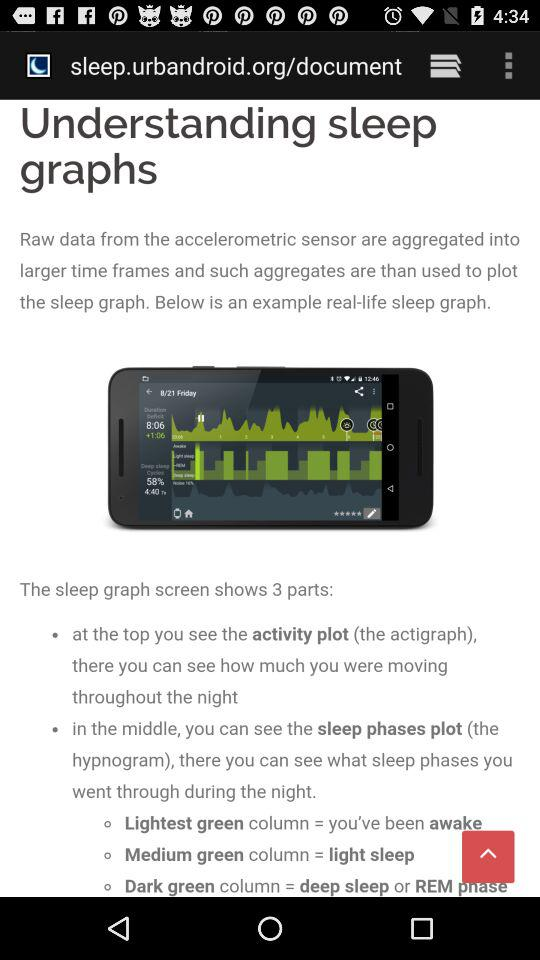How many different colors are used to represent sleep phases in the sleep phases plot?
Answer the question using a single word or phrase. 3 